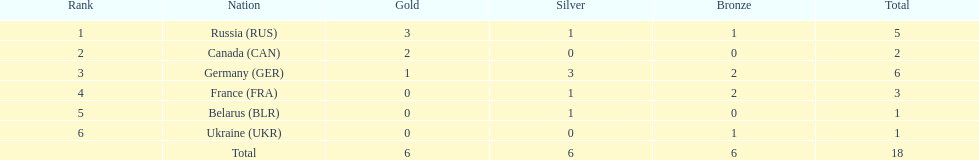What was the total number of silver medals awarded to the french and the germans in the 1994 winter olympic biathlon? 4. 